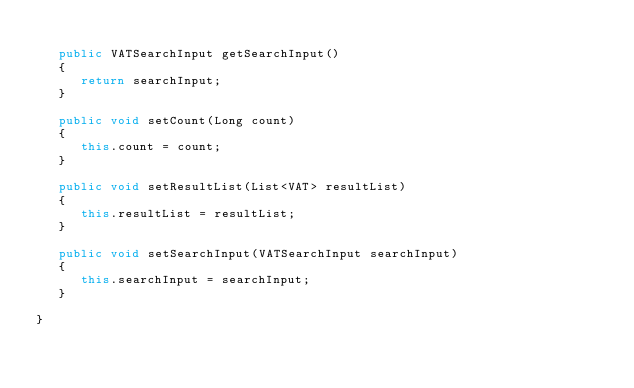<code> <loc_0><loc_0><loc_500><loc_500><_Java_>
   public VATSearchInput getSearchInput()
   {
      return searchInput;
   }

   public void setCount(Long count)
   {
      this.count = count;
   }

   public void setResultList(List<VAT> resultList)
   {
      this.resultList = resultList;
   }

   public void setSearchInput(VATSearchInput searchInput)
   {
      this.searchInput = searchInput;
   }

}
</code> 